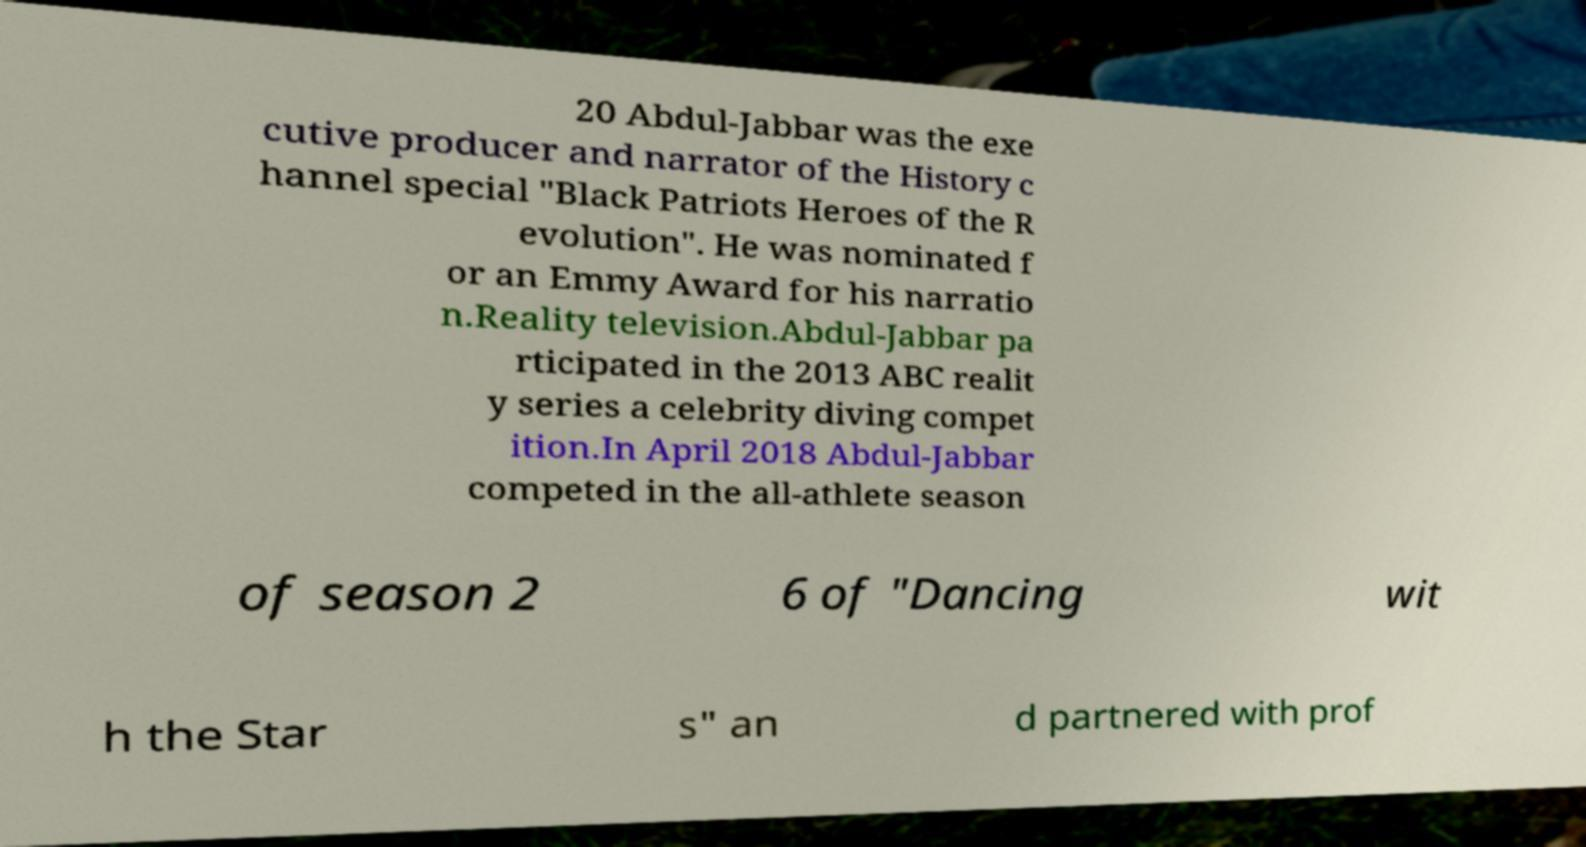Please read and relay the text visible in this image. What does it say? 20 Abdul-Jabbar was the exe cutive producer and narrator of the History c hannel special "Black Patriots Heroes of the R evolution". He was nominated f or an Emmy Award for his narratio n.Reality television.Abdul-Jabbar pa rticipated in the 2013 ABC realit y series a celebrity diving compet ition.In April 2018 Abdul-Jabbar competed in the all-athlete season of season 2 6 of "Dancing wit h the Star s" an d partnered with prof 